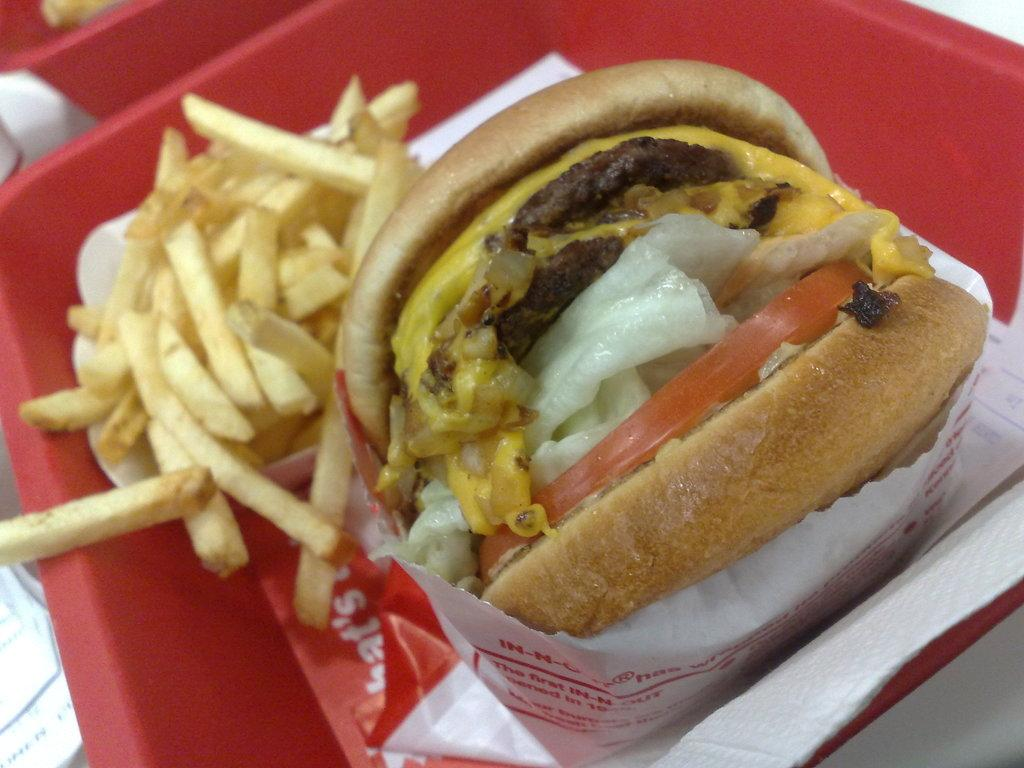What type of food can be seen in the image? There is food in the image, specifically a burger and french fries. How is the burger presented in the image? The burger is wrapped in paper in the image. What accompanies the burger on the plate? There are french fries on the plate with the burger. What type of reaction does the library have to the food in the image? There is no library present in the image, so it cannot have a reaction to the food. 